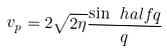<formula> <loc_0><loc_0><loc_500><loc_500>v _ { p } = 2 \sqrt { 2 \eta } \frac { \sin \ h a l f q } { q }</formula> 